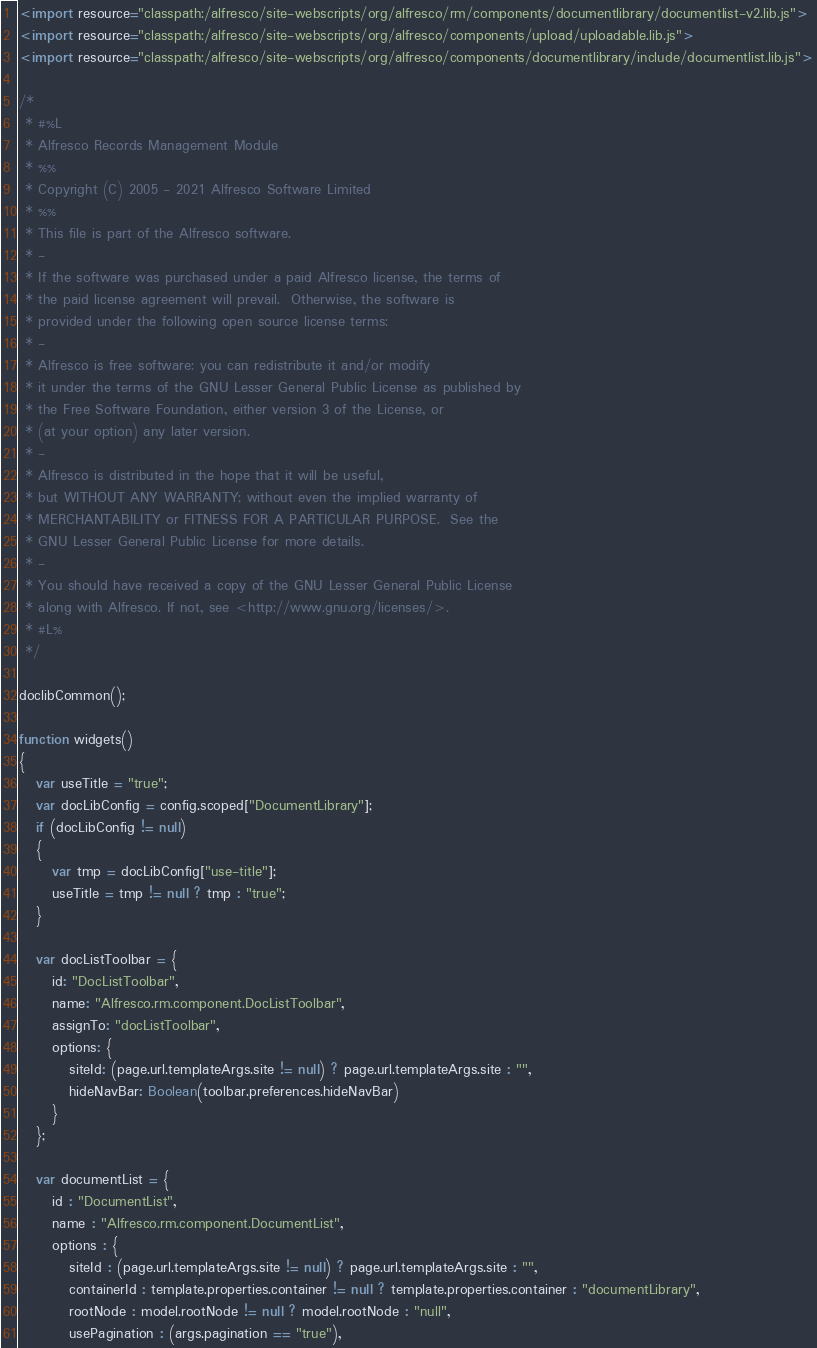Convert code to text. <code><loc_0><loc_0><loc_500><loc_500><_JavaScript_><import resource="classpath:/alfresco/site-webscripts/org/alfresco/rm/components/documentlibrary/documentlist-v2.lib.js">
<import resource="classpath:/alfresco/site-webscripts/org/alfresco/components/upload/uploadable.lib.js">
<import resource="classpath:/alfresco/site-webscripts/org/alfresco/components/documentlibrary/include/documentlist.lib.js">

/*
 * #%L
 * Alfresco Records Management Module
 * %%
 * Copyright (C) 2005 - 2021 Alfresco Software Limited
 * %%
 * This file is part of the Alfresco software.
 * -
 * If the software was purchased under a paid Alfresco license, the terms of
 * the paid license agreement will prevail.  Otherwise, the software is
 * provided under the following open source license terms:
 * -
 * Alfresco is free software: you can redistribute it and/or modify
 * it under the terms of the GNU Lesser General Public License as published by
 * the Free Software Foundation, either version 3 of the License, or
 * (at your option) any later version.
 * -
 * Alfresco is distributed in the hope that it will be useful,
 * but WITHOUT ANY WARRANTY; without even the implied warranty of
 * MERCHANTABILITY or FITNESS FOR A PARTICULAR PURPOSE.  See the
 * GNU Lesser General Public License for more details.
 * -
 * You should have received a copy of the GNU Lesser General Public License
 * along with Alfresco. If not, see <http://www.gnu.org/licenses/>.
 * #L%
 */

doclibCommon();

function widgets()
{
   var useTitle = "true";
   var docLibConfig = config.scoped["DocumentLibrary"];
   if (docLibConfig != null)
   {
      var tmp = docLibConfig["use-title"];
      useTitle = tmp != null ? tmp : "true";
   }

   var docListToolbar = {
      id: "DocListToolbar",
      name: "Alfresco.rm.component.DocListToolbar",
      assignTo: "docListToolbar",
      options: {
         siteId: (page.url.templateArgs.site != null) ? page.url.templateArgs.site : "",
         hideNavBar: Boolean(toolbar.preferences.hideNavBar)
      }
   };

   var documentList = {
      id : "DocumentList",
      name : "Alfresco.rm.component.DocumentList",
      options : {
         siteId : (page.url.templateArgs.site != null) ? page.url.templateArgs.site : "",
         containerId : template.properties.container != null ? template.properties.container : "documentLibrary",
         rootNode : model.rootNode != null ? model.rootNode : "null",
         usePagination : (args.pagination == "true"),</code> 